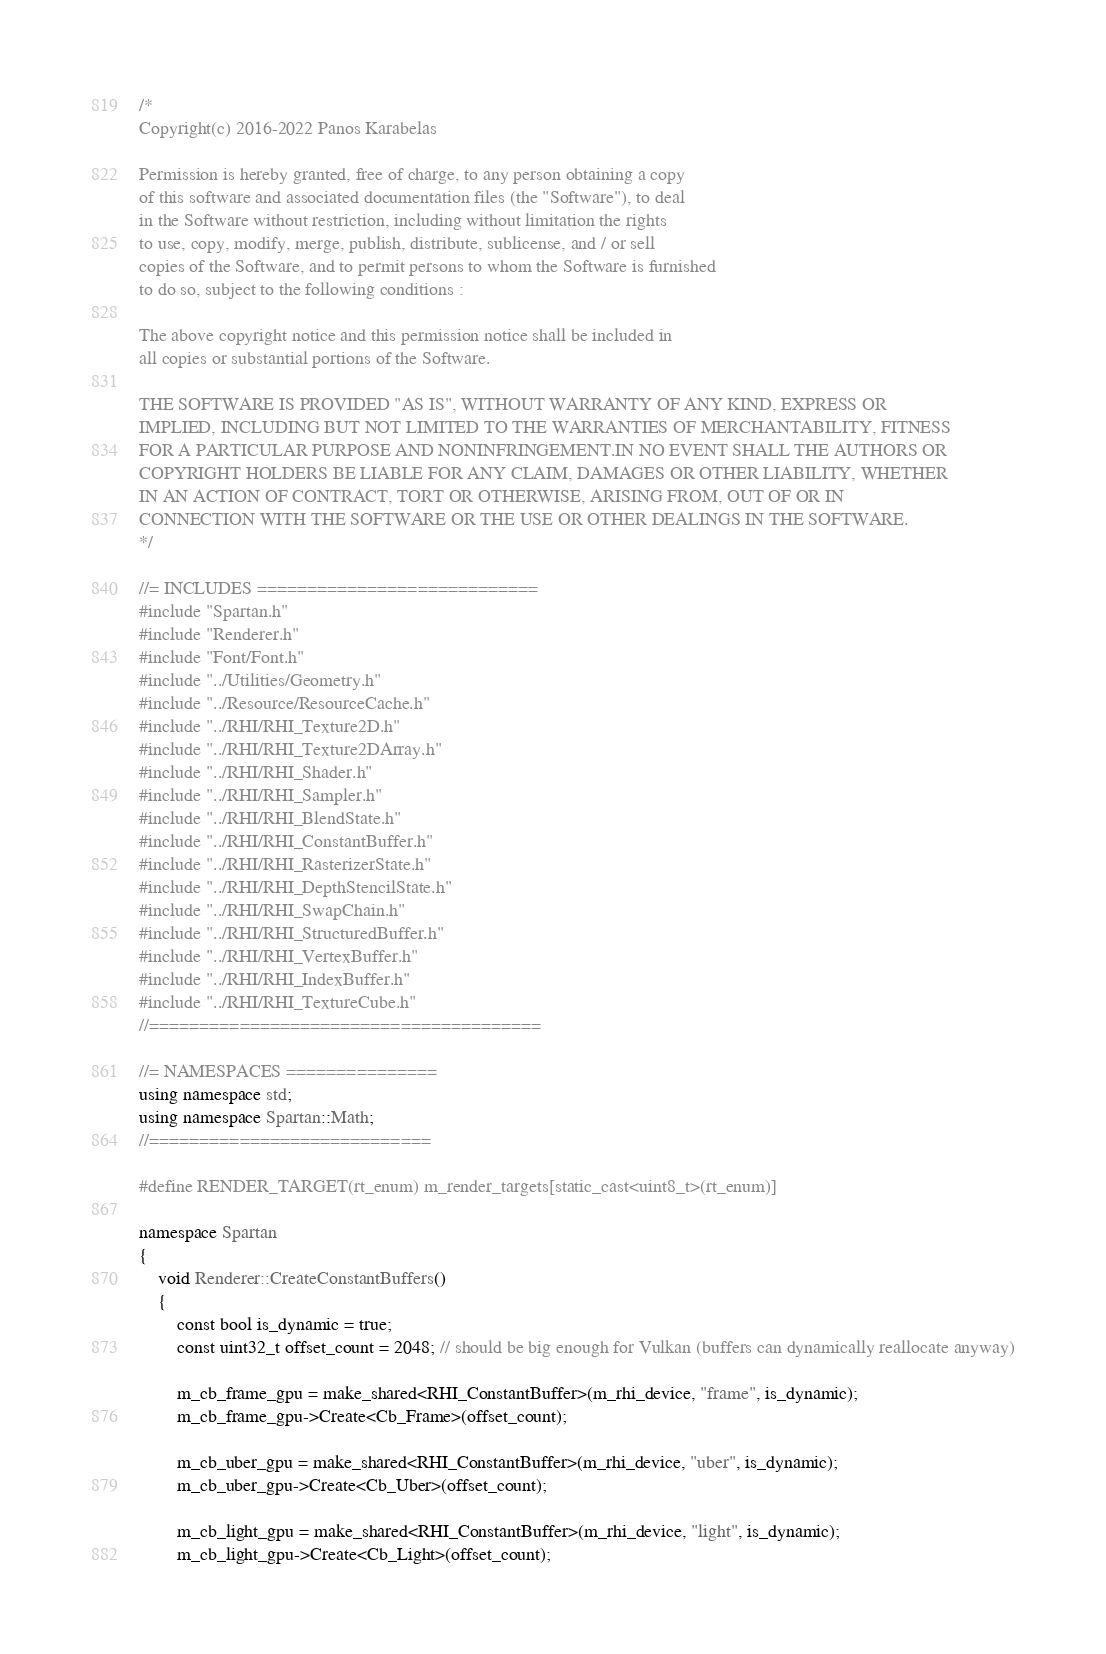<code> <loc_0><loc_0><loc_500><loc_500><_C++_>/*
Copyright(c) 2016-2022 Panos Karabelas

Permission is hereby granted, free of charge, to any person obtaining a copy
of this software and associated documentation files (the "Software"), to deal
in the Software without restriction, including without limitation the rights
to use, copy, modify, merge, publish, distribute, sublicense, and / or sell
copies of the Software, and to permit persons to whom the Software is furnished
to do so, subject to the following conditions :

The above copyright notice and this permission notice shall be included in
all copies or substantial portions of the Software.

THE SOFTWARE IS PROVIDED "AS IS", WITHOUT WARRANTY OF ANY KIND, EXPRESS OR
IMPLIED, INCLUDING BUT NOT LIMITED TO THE WARRANTIES OF MERCHANTABILITY, FITNESS
FOR A PARTICULAR PURPOSE AND NONINFRINGEMENT.IN NO EVENT SHALL THE AUTHORS OR
COPYRIGHT HOLDERS BE LIABLE FOR ANY CLAIM, DAMAGES OR OTHER LIABILITY, WHETHER
IN AN ACTION OF CONTRACT, TORT OR OTHERWISE, ARISING FROM, OUT OF OR IN
CONNECTION WITH THE SOFTWARE OR THE USE OR OTHER DEALINGS IN THE SOFTWARE.
*/

//= INCLUDES ============================
#include "Spartan.h"
#include "Renderer.h"
#include "Font/Font.h"
#include "../Utilities/Geometry.h"
#include "../Resource/ResourceCache.h"
#include "../RHI/RHI_Texture2D.h"
#include "../RHI/RHI_Texture2DArray.h"
#include "../RHI/RHI_Shader.h"
#include "../RHI/RHI_Sampler.h"
#include "../RHI/RHI_BlendState.h"
#include "../RHI/RHI_ConstantBuffer.h"
#include "../RHI/RHI_RasterizerState.h"
#include "../RHI/RHI_DepthStencilState.h"
#include "../RHI/RHI_SwapChain.h"
#include "../RHI/RHI_StructuredBuffer.h"
#include "../RHI/RHI_VertexBuffer.h"
#include "../RHI/RHI_IndexBuffer.h"
#include "../RHI/RHI_TextureCube.h"
//=======================================

//= NAMESPACES ===============
using namespace std;
using namespace Spartan::Math;
//============================

#define RENDER_TARGET(rt_enum) m_render_targets[static_cast<uint8_t>(rt_enum)]

namespace Spartan
{
    void Renderer::CreateConstantBuffers()
    {
        const bool is_dynamic = true;
        const uint32_t offset_count = 2048; // should be big enough for Vulkan (buffers can dynamically reallocate anyway)

        m_cb_frame_gpu = make_shared<RHI_ConstantBuffer>(m_rhi_device, "frame", is_dynamic);
        m_cb_frame_gpu->Create<Cb_Frame>(offset_count);

        m_cb_uber_gpu = make_shared<RHI_ConstantBuffer>(m_rhi_device, "uber", is_dynamic);
        m_cb_uber_gpu->Create<Cb_Uber>(offset_count);

        m_cb_light_gpu = make_shared<RHI_ConstantBuffer>(m_rhi_device, "light", is_dynamic);
        m_cb_light_gpu->Create<Cb_Light>(offset_count);
</code> 